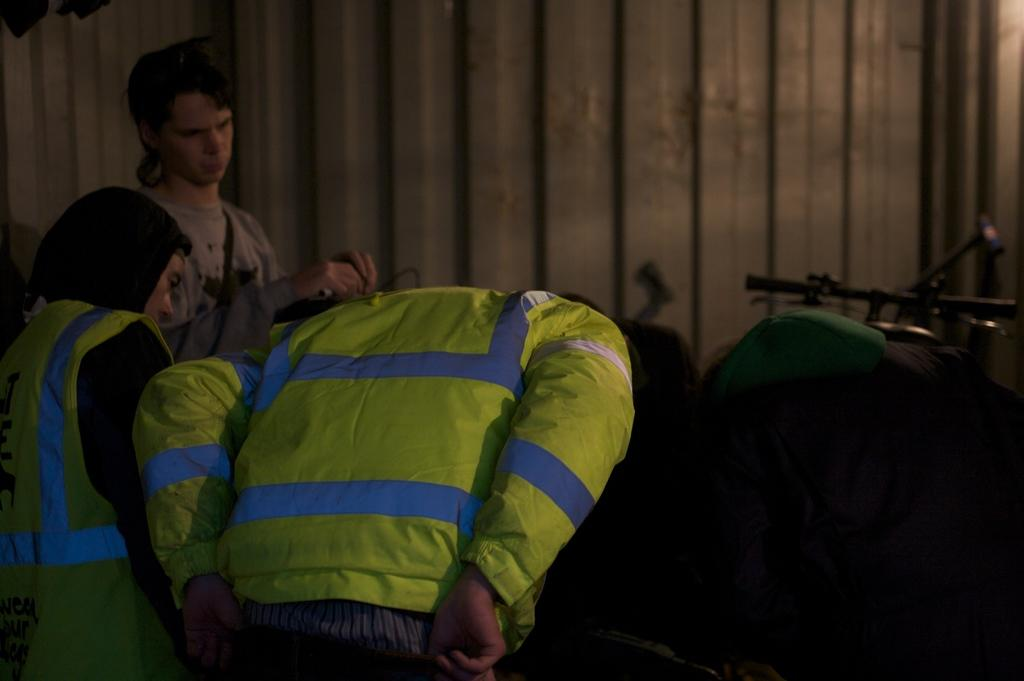How many people are in the image? There is a group of people in the image, but the exact number cannot be determined from the provided facts. What can be seen on the right side of the image? There is an object on the right side of the image. What is visible behind the people in the image? There is a wall visible behind the people in the image. What type of juice is being served on the boat in the image? There is no boat or juice present in the image. Is there a spy among the group of people in the image? There is no information about the people's identities or any indication of a spy in the image. 